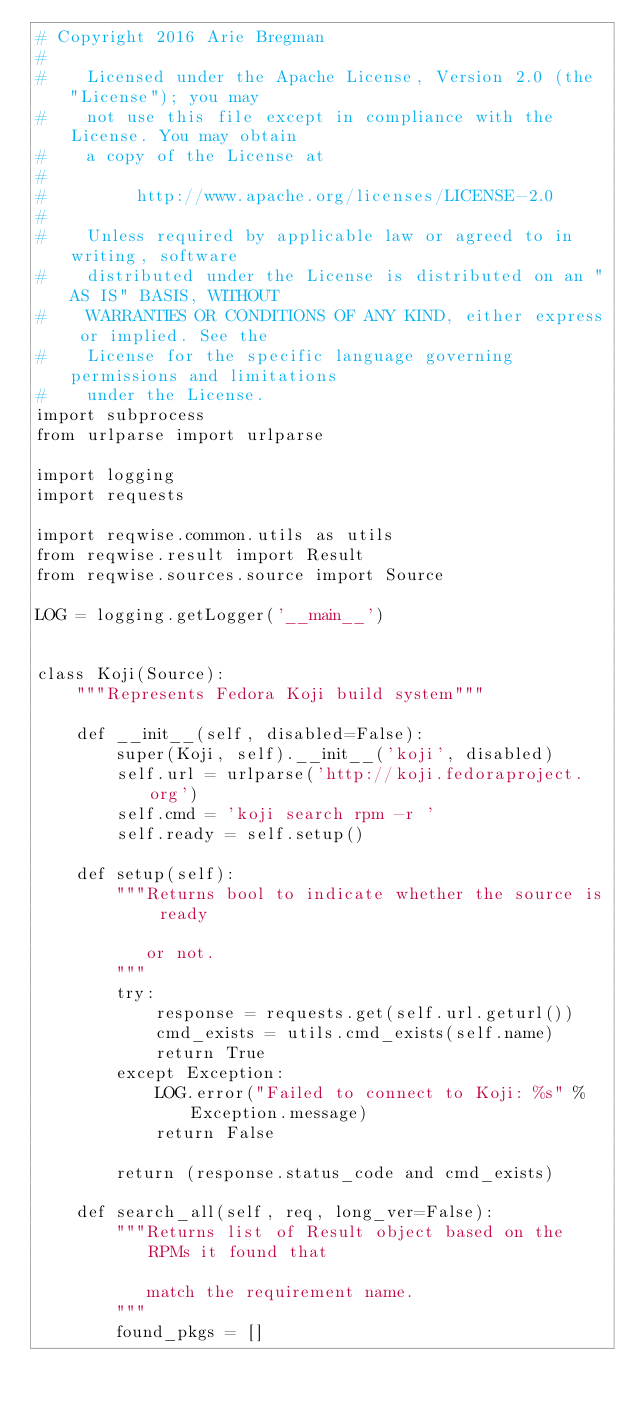Convert code to text. <code><loc_0><loc_0><loc_500><loc_500><_Python_># Copyright 2016 Arie Bregman
#
#    Licensed under the Apache License, Version 2.0 (the "License"); you may
#    not use this file except in compliance with the License. You may obtain
#    a copy of the License at
#
#         http://www.apache.org/licenses/LICENSE-2.0
#
#    Unless required by applicable law or agreed to in writing, software
#    distributed under the License is distributed on an "AS IS" BASIS, WITHOUT
#    WARRANTIES OR CONDITIONS OF ANY KIND, either express or implied. See the
#    License for the specific language governing permissions and limitations
#    under the License.
import subprocess
from urlparse import urlparse

import logging
import requests

import reqwise.common.utils as utils
from reqwise.result import Result
from reqwise.sources.source import Source

LOG = logging.getLogger('__main__')


class Koji(Source):
    """Represents Fedora Koji build system"""

    def __init__(self, disabled=False):
        super(Koji, self).__init__('koji', disabled)
        self.url = urlparse('http://koji.fedoraproject.org')
        self.cmd = 'koji search rpm -r '
        self.ready = self.setup()

    def setup(self):
        """Returns bool to indicate whether the source is ready

           or not.
        """
        try:
            response = requests.get(self.url.geturl())
            cmd_exists = utils.cmd_exists(self.name)
            return True
        except Exception:
            LOG.error("Failed to connect to Koji: %s" % Exception.message)
            return False

        return (response.status_code and cmd_exists)

    def search_all(self, req, long_ver=False):
        """Returns list of Result object based on the RPMs it found that

           match the requirement name.
        """
        found_pkgs = []</code> 